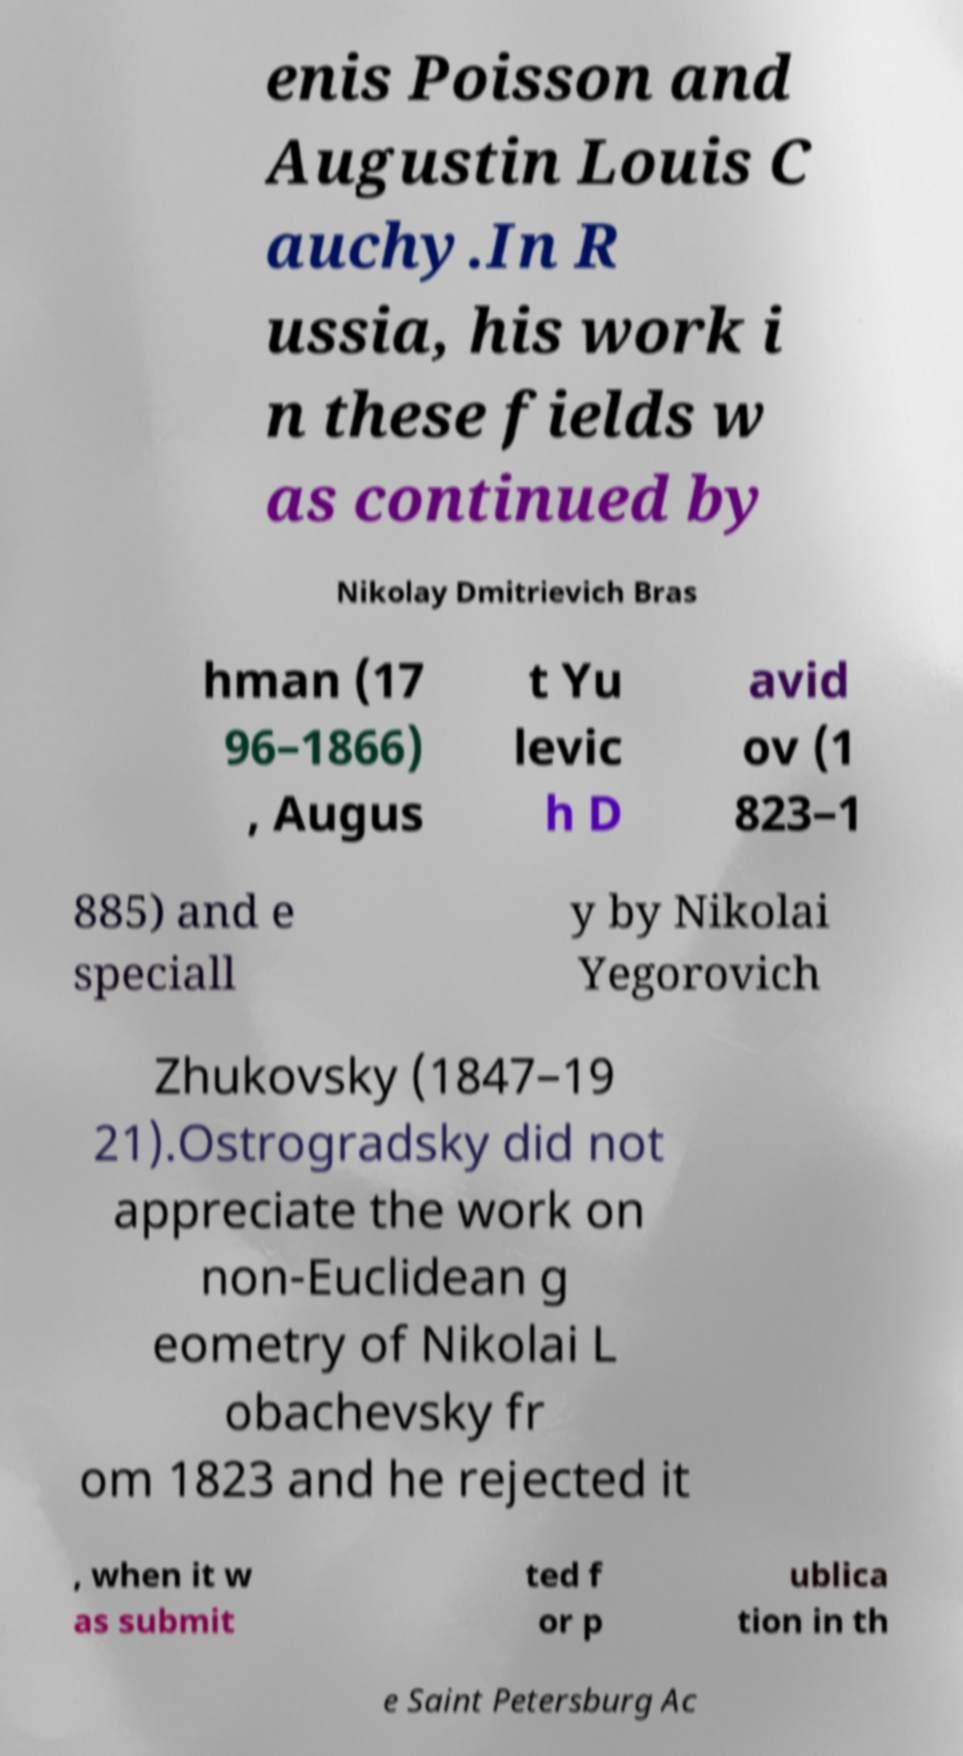I need the written content from this picture converted into text. Can you do that? enis Poisson and Augustin Louis C auchy.In R ussia, his work i n these fields w as continued by Nikolay Dmitrievich Bras hman (17 96–1866) , Augus t Yu levic h D avid ov (1 823–1 885) and e speciall y by Nikolai Yegorovich Zhukovsky (1847–19 21).Ostrogradsky did not appreciate the work on non-Euclidean g eometry of Nikolai L obachevsky fr om 1823 and he rejected it , when it w as submit ted f or p ublica tion in th e Saint Petersburg Ac 